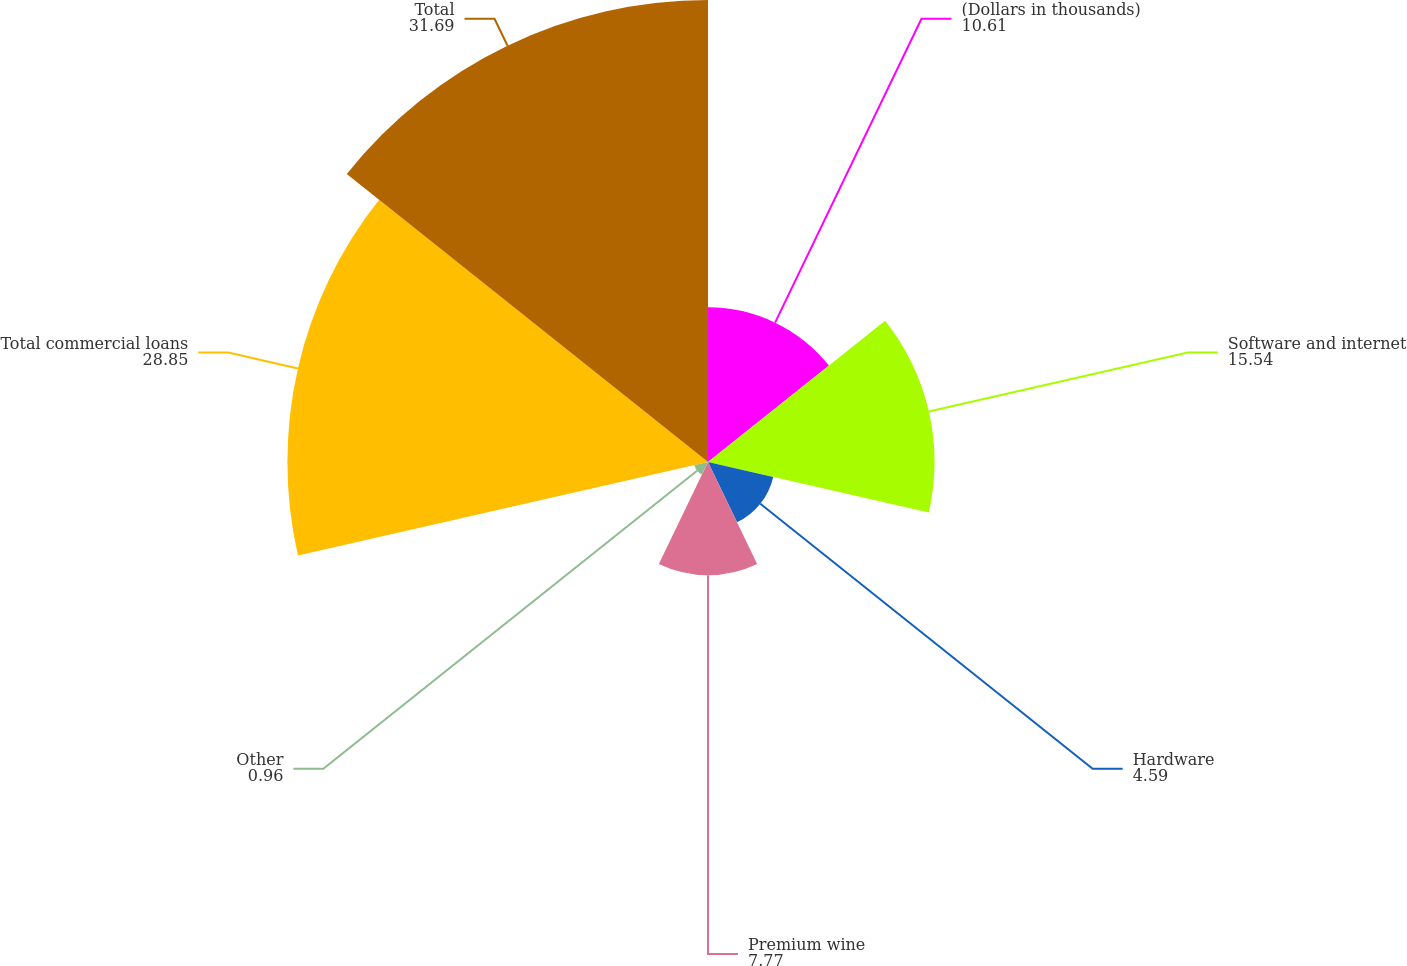Convert chart. <chart><loc_0><loc_0><loc_500><loc_500><pie_chart><fcel>(Dollars in thousands)<fcel>Software and internet<fcel>Hardware<fcel>Premium wine<fcel>Other<fcel>Total commercial loans<fcel>Total<nl><fcel>10.61%<fcel>15.54%<fcel>4.59%<fcel>7.77%<fcel>0.96%<fcel>28.85%<fcel>31.69%<nl></chart> 